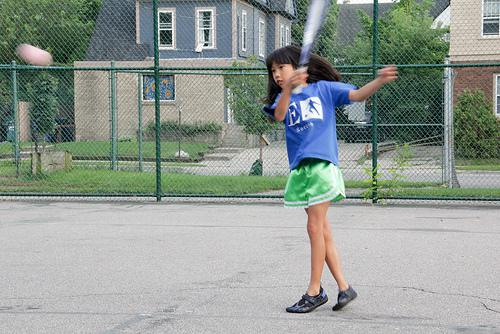Question: who is holding the racket?
Choices:
A. A girl.
B. A boy.
C. A lady.
D. A man.
Answer with the letter. Answer: A Question: why is she standing that way?
Choices:
A. To kick the ball.
B. To take down the other fighter.
C. To see the ocean.
D. To hit ball.
Answer with the letter. Answer: D Question: what color is her shirt?
Choices:
A. Blue and white.
B. Red.
C. Pink.
D. Blue.
Answer with the letter. Answer: A Question: where is she playing?
Choices:
A. Ocean.
B. Soccer field.
C. Tennis court.
D. Octagon.
Answer with the letter. Answer: C Question: what is in the background?
Choices:
A. Horses.
B. Houses.
C. Zebras.
D. Cattle.
Answer with the letter. Answer: B 